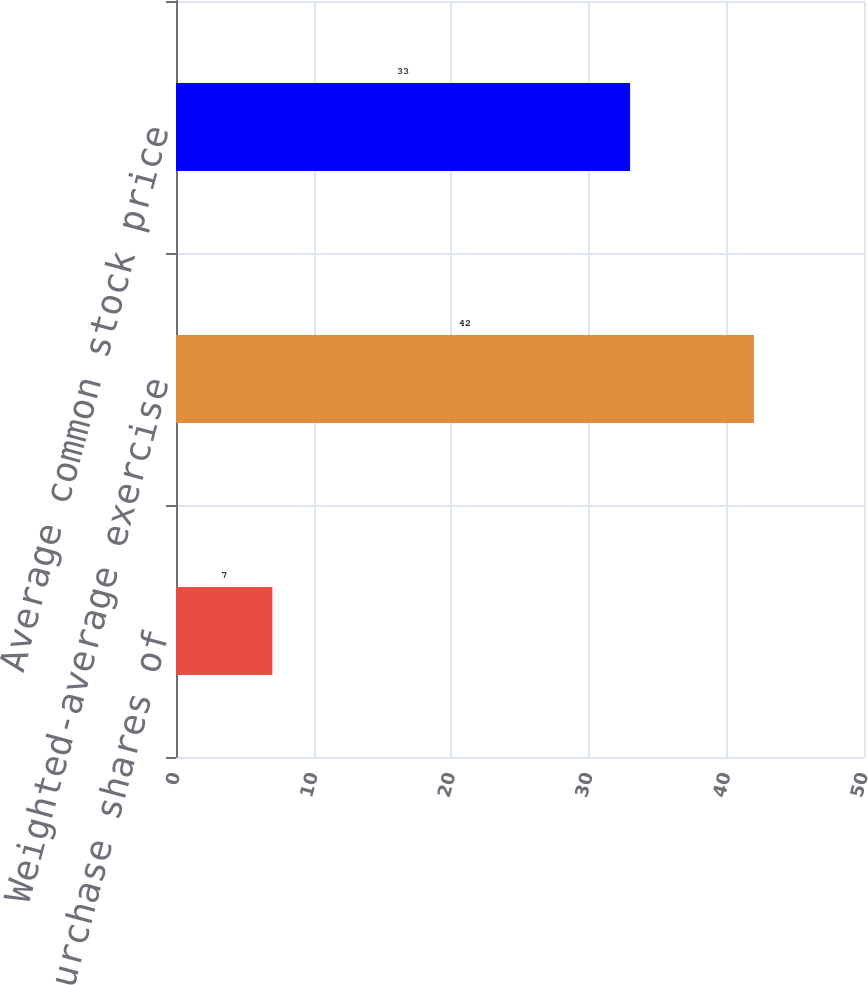Convert chart. <chart><loc_0><loc_0><loc_500><loc_500><bar_chart><fcel>Options to purchase shares of<fcel>Weighted-average exercise<fcel>Average common stock price<nl><fcel>7<fcel>42<fcel>33<nl></chart> 